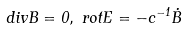<formula> <loc_0><loc_0><loc_500><loc_500>d i v { B } = 0 , { \, } { \, } r o t { E } = - c ^ { - 1 } \dot { B }</formula> 